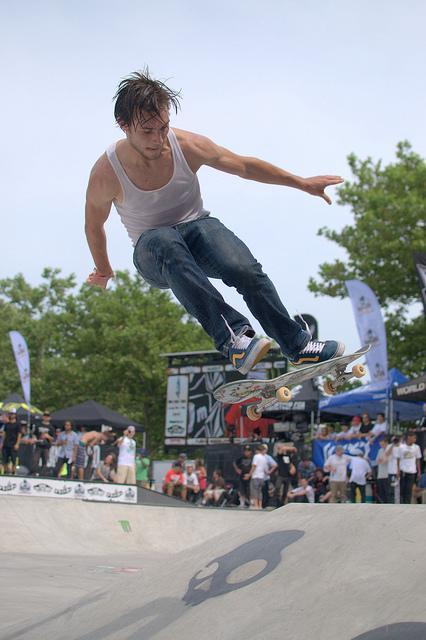How many people can be seen?
Give a very brief answer. 2. 